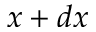Convert formula to latex. <formula><loc_0><loc_0><loc_500><loc_500>x + d x</formula> 